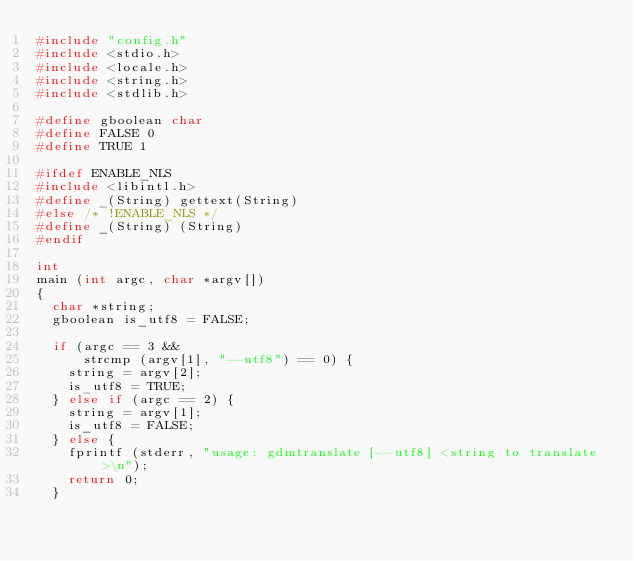<code> <loc_0><loc_0><loc_500><loc_500><_C_>#include "config.h"
#include <stdio.h>
#include <locale.h>
#include <string.h>
#include <stdlib.h>

#define gboolean char
#define FALSE 0
#define TRUE 1

#ifdef ENABLE_NLS
#include <libintl.h>
#define _(String) gettext(String)
#else /* !ENABLE_NLS */
#define _(String) (String)
#endif

int
main (int argc, char *argv[])
{
	char *string;
	gboolean is_utf8 = FALSE;

	if (argc == 3 &&
	    strcmp (argv[1], "--utf8") == 0) {
		string = argv[2];
		is_utf8 = TRUE;
	} else if (argc == 2) {
		string = argv[1];
		is_utf8 = FALSE;
	} else {
		fprintf (stderr, "usage: gdmtranslate [--utf8] <string to translate>\n");
		return 0;
	}
</code> 